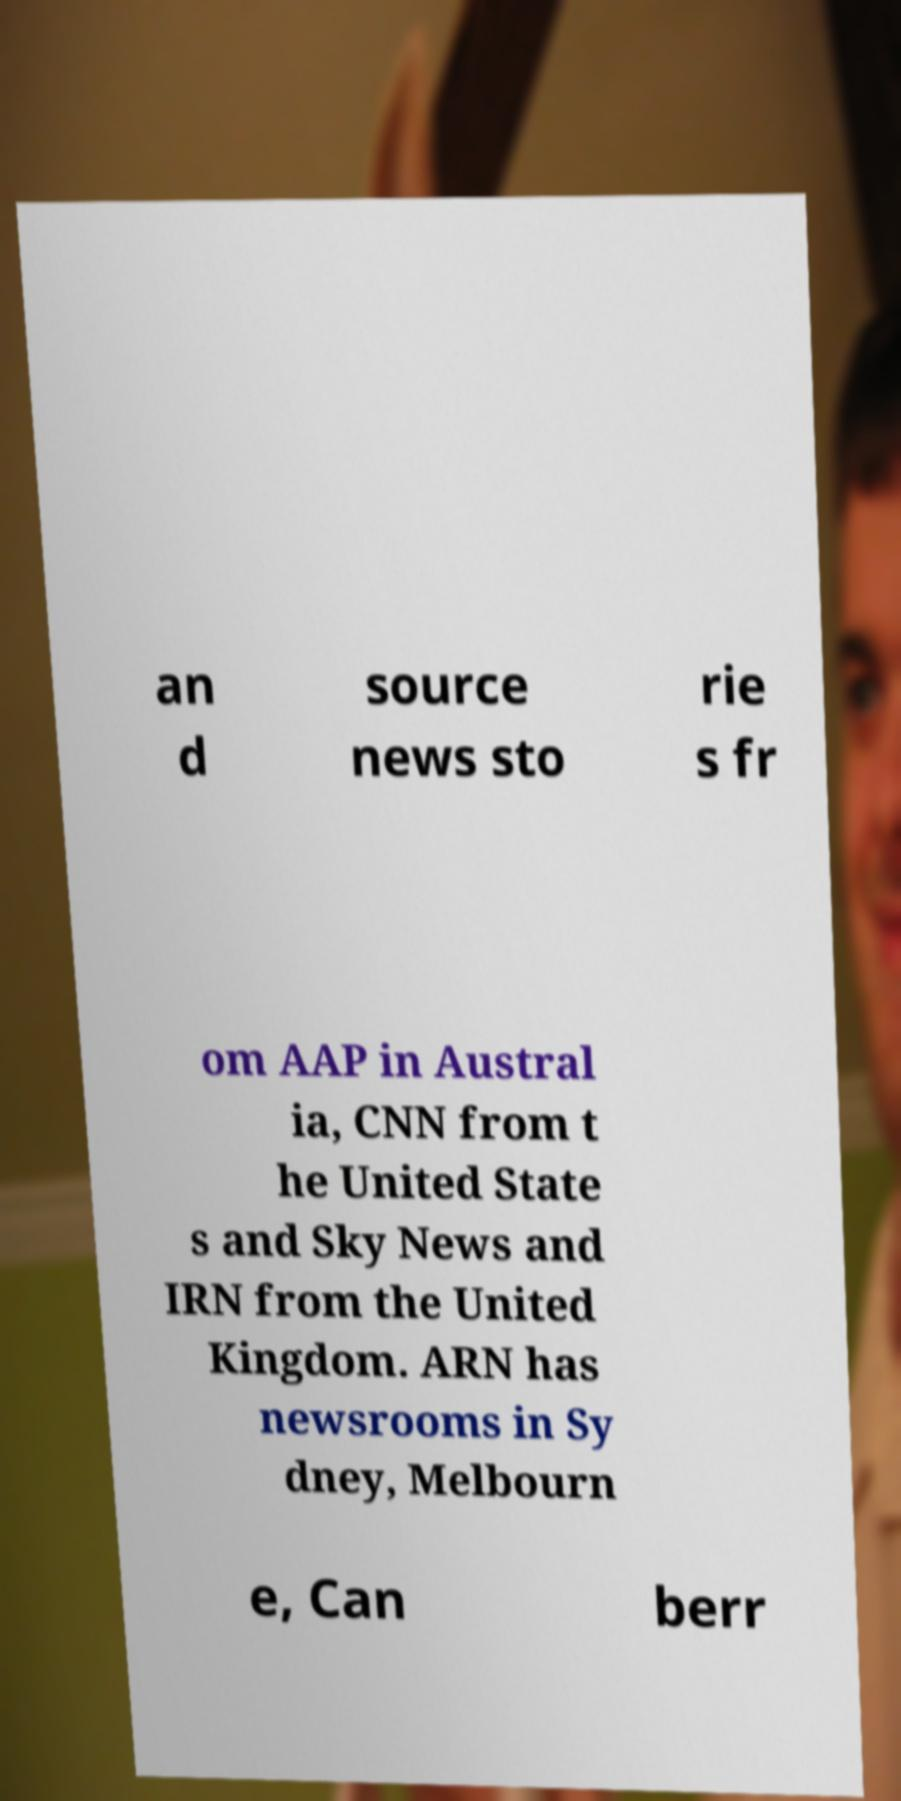There's text embedded in this image that I need extracted. Can you transcribe it verbatim? an d source news sto rie s fr om AAP in Austral ia, CNN from t he United State s and Sky News and IRN from the United Kingdom. ARN has newsrooms in Sy dney, Melbourn e, Can berr 